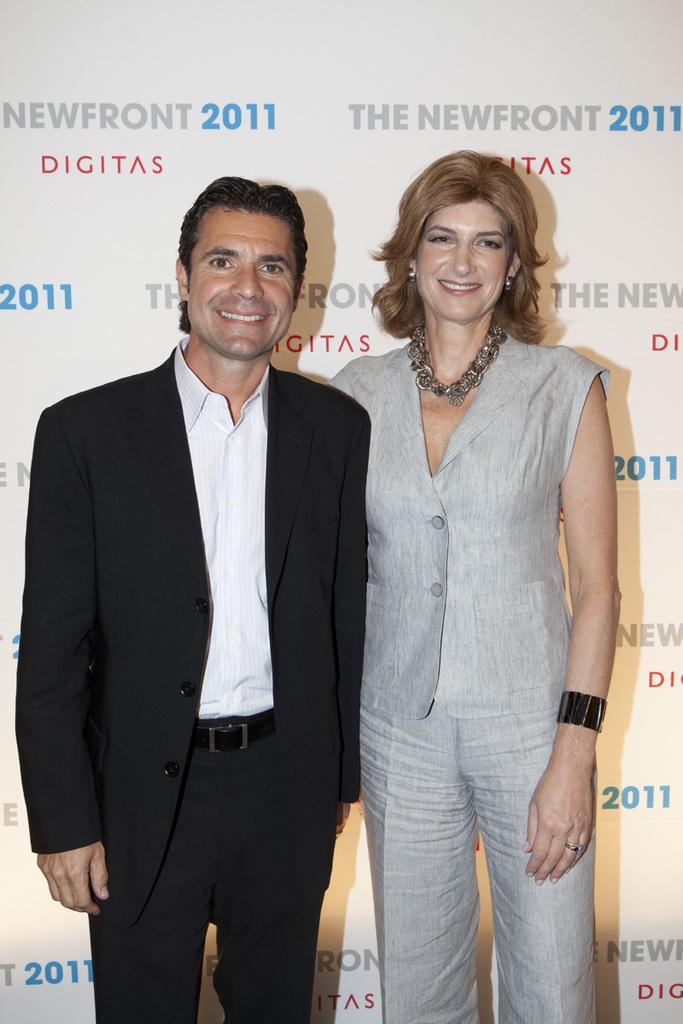Describe this image in one or two sentences. In this image a person wearing a suit is standing beside to a woman. Behind them there is a banner having some text on it. 